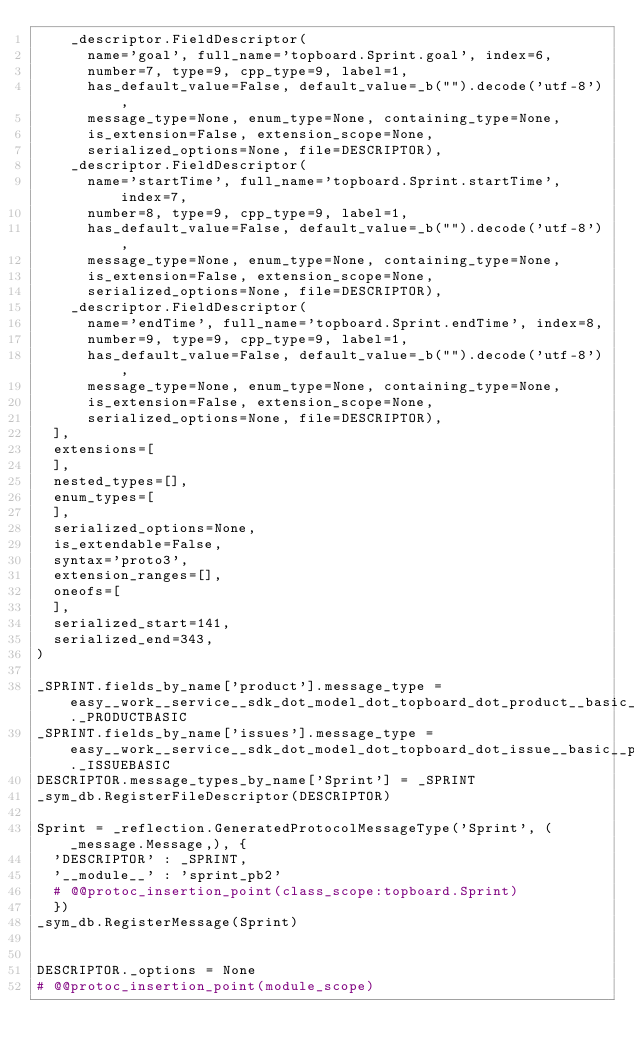<code> <loc_0><loc_0><loc_500><loc_500><_Python_>    _descriptor.FieldDescriptor(
      name='goal', full_name='topboard.Sprint.goal', index=6,
      number=7, type=9, cpp_type=9, label=1,
      has_default_value=False, default_value=_b("").decode('utf-8'),
      message_type=None, enum_type=None, containing_type=None,
      is_extension=False, extension_scope=None,
      serialized_options=None, file=DESCRIPTOR),
    _descriptor.FieldDescriptor(
      name='startTime', full_name='topboard.Sprint.startTime', index=7,
      number=8, type=9, cpp_type=9, label=1,
      has_default_value=False, default_value=_b("").decode('utf-8'),
      message_type=None, enum_type=None, containing_type=None,
      is_extension=False, extension_scope=None,
      serialized_options=None, file=DESCRIPTOR),
    _descriptor.FieldDescriptor(
      name='endTime', full_name='topboard.Sprint.endTime', index=8,
      number=9, type=9, cpp_type=9, label=1,
      has_default_value=False, default_value=_b("").decode('utf-8'),
      message_type=None, enum_type=None, containing_type=None,
      is_extension=False, extension_scope=None,
      serialized_options=None, file=DESCRIPTOR),
  ],
  extensions=[
  ],
  nested_types=[],
  enum_types=[
  ],
  serialized_options=None,
  is_extendable=False,
  syntax='proto3',
  extension_ranges=[],
  oneofs=[
  ],
  serialized_start=141,
  serialized_end=343,
)

_SPRINT.fields_by_name['product'].message_type = easy__work__service__sdk_dot_model_dot_topboard_dot_product__basic__pb2._PRODUCTBASIC
_SPRINT.fields_by_name['issues'].message_type = easy__work__service__sdk_dot_model_dot_topboard_dot_issue__basic__pb2._ISSUEBASIC
DESCRIPTOR.message_types_by_name['Sprint'] = _SPRINT
_sym_db.RegisterFileDescriptor(DESCRIPTOR)

Sprint = _reflection.GeneratedProtocolMessageType('Sprint', (_message.Message,), {
  'DESCRIPTOR' : _SPRINT,
  '__module__' : 'sprint_pb2'
  # @@protoc_insertion_point(class_scope:topboard.Sprint)
  })
_sym_db.RegisterMessage(Sprint)


DESCRIPTOR._options = None
# @@protoc_insertion_point(module_scope)
</code> 